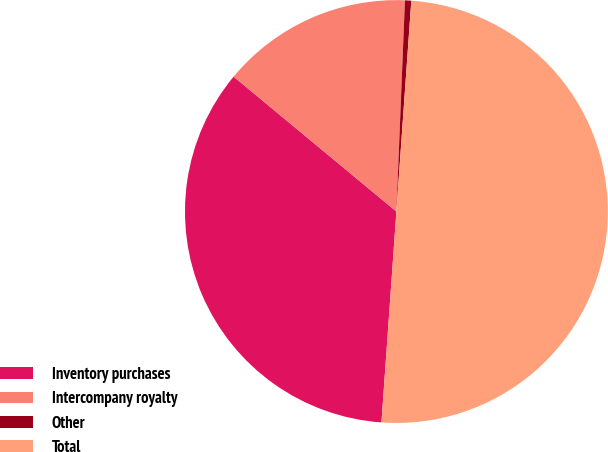Convert chart. <chart><loc_0><loc_0><loc_500><loc_500><pie_chart><fcel>Inventory purchases<fcel>Intercompany royalty<fcel>Other<fcel>Total<nl><fcel>34.89%<fcel>14.63%<fcel>0.48%<fcel>50.0%<nl></chart> 